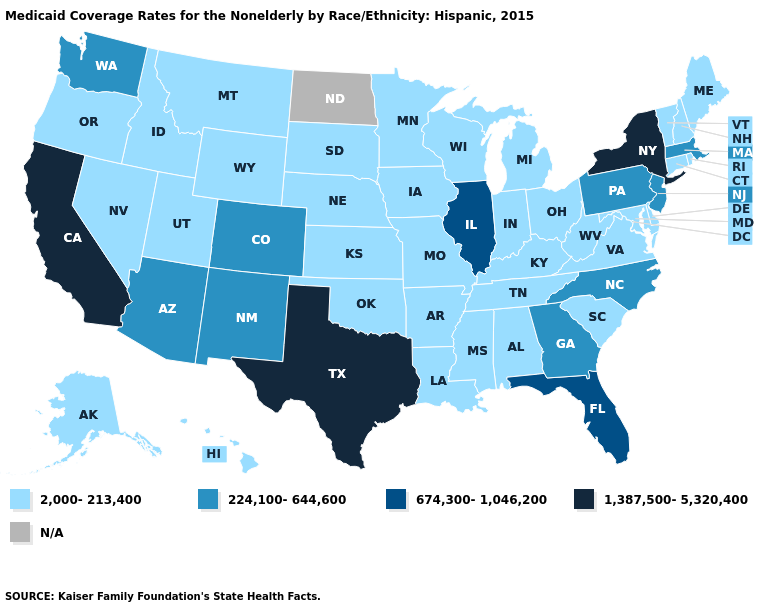What is the value of Texas?
Answer briefly. 1,387,500-5,320,400. What is the lowest value in the USA?
Give a very brief answer. 2,000-213,400. Does the first symbol in the legend represent the smallest category?
Keep it brief. Yes. Among the states that border Nevada , which have the highest value?
Be succinct. California. What is the value of Montana?
Quick response, please. 2,000-213,400. What is the value of Washington?
Quick response, please. 224,100-644,600. Among the states that border Washington , which have the lowest value?
Quick response, please. Idaho, Oregon. What is the value of Pennsylvania?
Answer briefly. 224,100-644,600. What is the value of Michigan?
Be succinct. 2,000-213,400. Does Rhode Island have the lowest value in the Northeast?
Be succinct. Yes. 